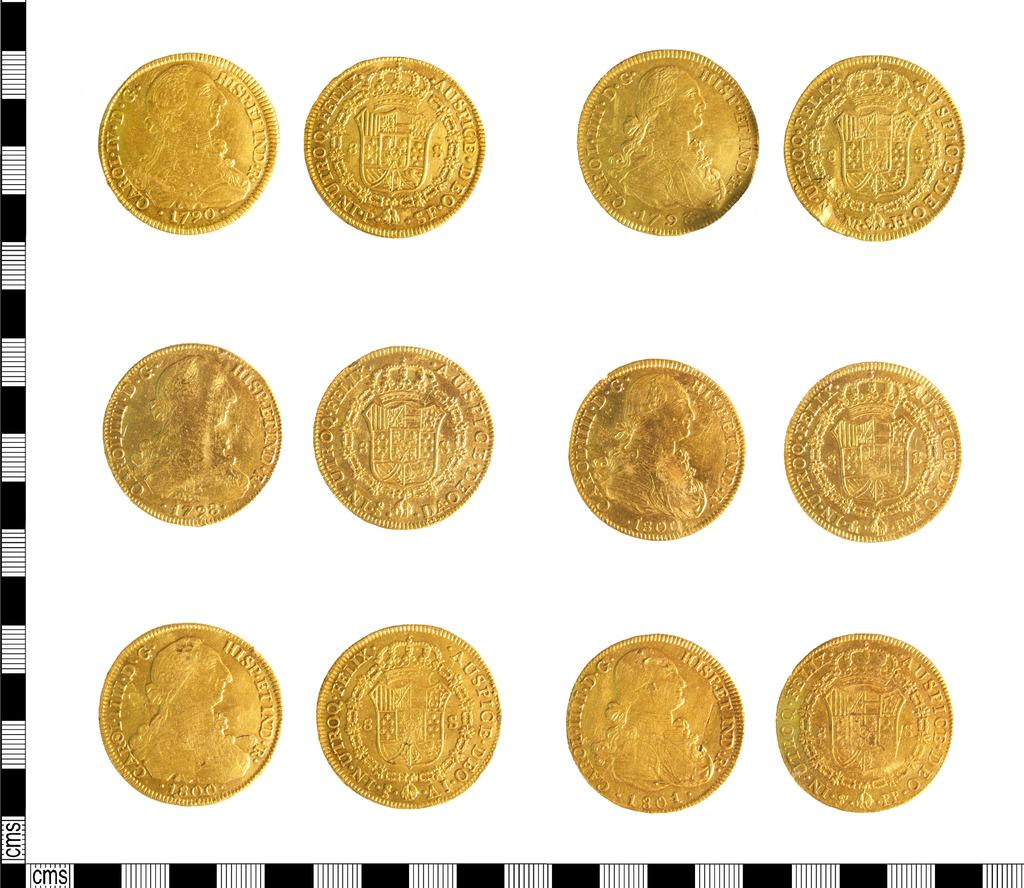<image>
Present a compact description of the photo's key features. Many coins on display including one with the year 1790 on it. 